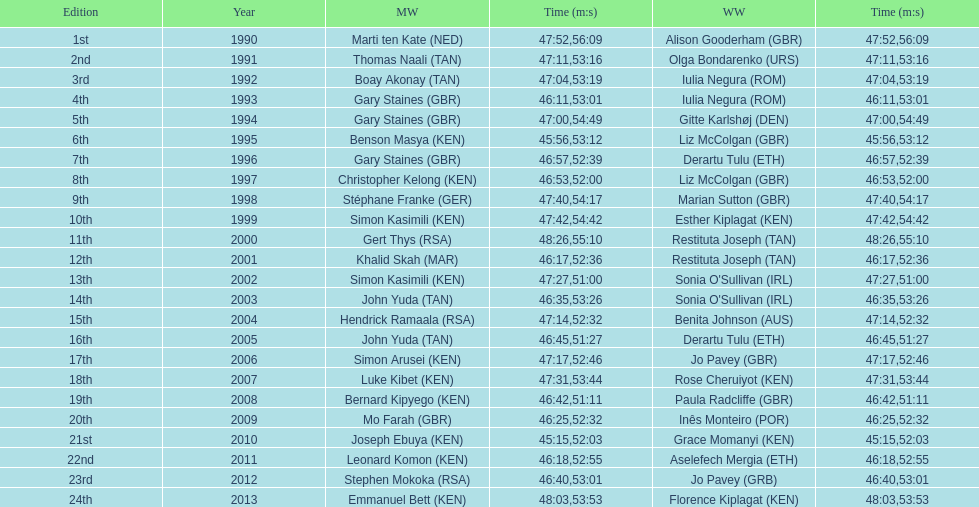Who has the fastest recorded finish for the men's bupa great south run, between 1990 and 2013? Joseph Ebuya (KEN). Help me parse the entirety of this table. {'header': ['Edition', 'Year', 'MW', 'Time (m:s)', 'WW', 'Time (m:s)'], 'rows': [['1st', '1990', 'Marti ten Kate\xa0(NED)', '47:52', 'Alison Gooderham\xa0(GBR)', '56:09'], ['2nd', '1991', 'Thomas Naali\xa0(TAN)', '47:11', 'Olga Bondarenko\xa0(URS)', '53:16'], ['3rd', '1992', 'Boay Akonay\xa0(TAN)', '47:04', 'Iulia Negura\xa0(ROM)', '53:19'], ['4th', '1993', 'Gary Staines\xa0(GBR)', '46:11', 'Iulia Negura\xa0(ROM)', '53:01'], ['5th', '1994', 'Gary Staines\xa0(GBR)', '47:00', 'Gitte Karlshøj\xa0(DEN)', '54:49'], ['6th', '1995', 'Benson Masya\xa0(KEN)', '45:56', 'Liz McColgan\xa0(GBR)', '53:12'], ['7th', '1996', 'Gary Staines\xa0(GBR)', '46:57', 'Derartu Tulu\xa0(ETH)', '52:39'], ['8th', '1997', 'Christopher Kelong\xa0(KEN)', '46:53', 'Liz McColgan\xa0(GBR)', '52:00'], ['9th', '1998', 'Stéphane Franke\xa0(GER)', '47:40', 'Marian Sutton\xa0(GBR)', '54:17'], ['10th', '1999', 'Simon Kasimili\xa0(KEN)', '47:42', 'Esther Kiplagat\xa0(KEN)', '54:42'], ['11th', '2000', 'Gert Thys\xa0(RSA)', '48:26', 'Restituta Joseph\xa0(TAN)', '55:10'], ['12th', '2001', 'Khalid Skah\xa0(MAR)', '46:17', 'Restituta Joseph\xa0(TAN)', '52:36'], ['13th', '2002', 'Simon Kasimili\xa0(KEN)', '47:27', "Sonia O'Sullivan\xa0(IRL)", '51:00'], ['14th', '2003', 'John Yuda\xa0(TAN)', '46:35', "Sonia O'Sullivan\xa0(IRL)", '53:26'], ['15th', '2004', 'Hendrick Ramaala\xa0(RSA)', '47:14', 'Benita Johnson\xa0(AUS)', '52:32'], ['16th', '2005', 'John Yuda\xa0(TAN)', '46:45', 'Derartu Tulu\xa0(ETH)', '51:27'], ['17th', '2006', 'Simon Arusei\xa0(KEN)', '47:17', 'Jo Pavey\xa0(GBR)', '52:46'], ['18th', '2007', 'Luke Kibet\xa0(KEN)', '47:31', 'Rose Cheruiyot\xa0(KEN)', '53:44'], ['19th', '2008', 'Bernard Kipyego\xa0(KEN)', '46:42', 'Paula Radcliffe\xa0(GBR)', '51:11'], ['20th', '2009', 'Mo Farah\xa0(GBR)', '46:25', 'Inês Monteiro\xa0(POR)', '52:32'], ['21st', '2010', 'Joseph Ebuya\xa0(KEN)', '45:15', 'Grace Momanyi\xa0(KEN)', '52:03'], ['22nd', '2011', 'Leonard Komon\xa0(KEN)', '46:18', 'Aselefech Mergia\xa0(ETH)', '52:55'], ['23rd', '2012', 'Stephen Mokoka\xa0(RSA)', '46:40', 'Jo Pavey\xa0(GRB)', '53:01'], ['24th', '2013', 'Emmanuel Bett\xa0(KEN)', '48:03', 'Florence Kiplagat\xa0(KEN)', '53:53']]} 